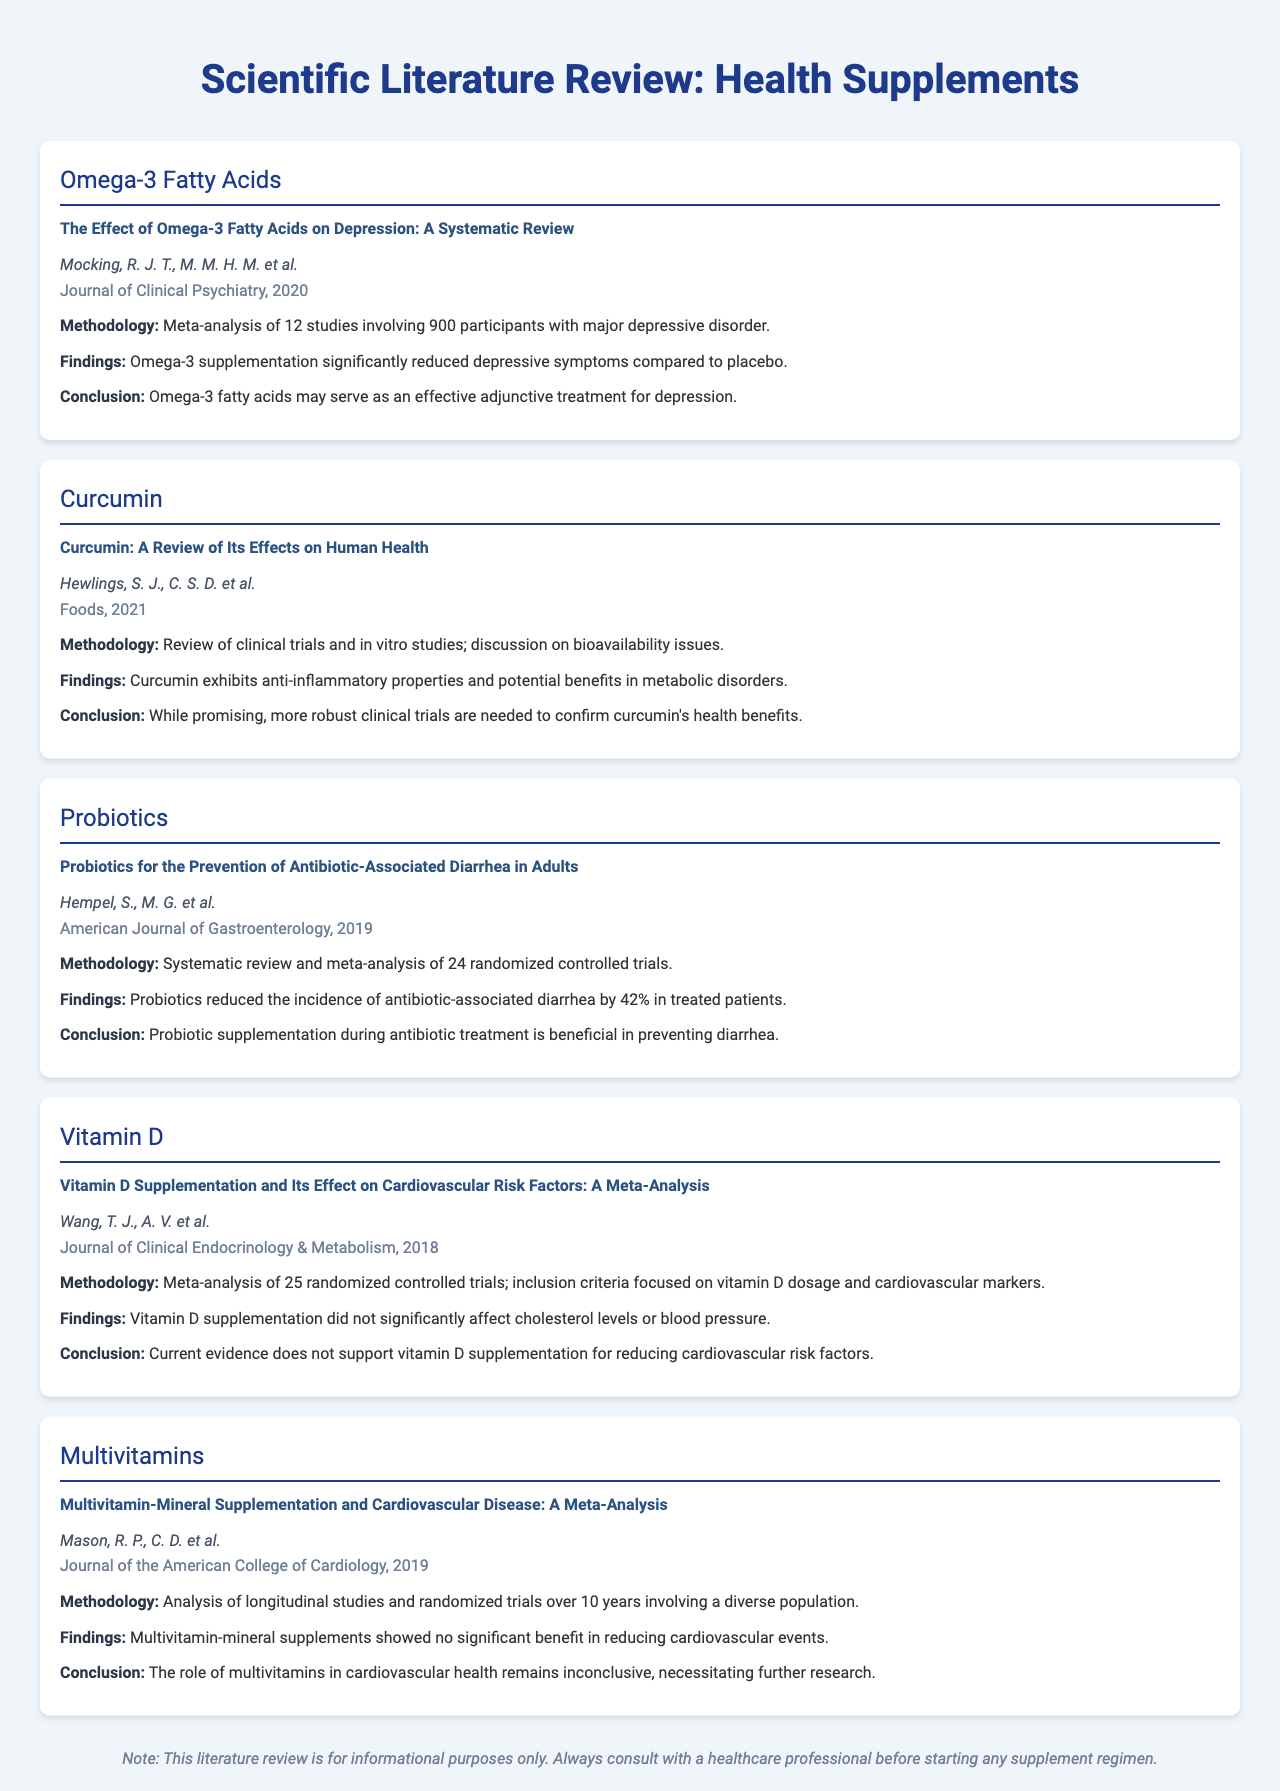What is the title of the study on Omega-3 Fatty Acids? The title of the study is explicitly mentioned within the document for Omega-3 Fatty Acids.
Answer: The Effect of Omega-3 Fatty Acids on Depression: A Systematic Review Who are the authors of the study on Curcumin? The authors of the Curcumin study are listed directly beneath the title in the document.
Answer: Hewlings, S. J., C. S. D. et al What year was the Probiotics study published? The publication year is specified in the document, providing a clear reference for the Probiotics study.
Answer: 2019 How many studies were included in the Vitamin D meta-analysis? The document outlines the details of the Vitamin D study, including the number of trials that were analyzed.
Answer: 25 What significant finding does the studies conclude about Multivitamins and cardiovascular events? The document presents the findings of the Multivitamin study concerning cardiovascular health outcomes.
Answer: No significant benefit What is the main conclusion regarding Curcumin's health benefits? The conclusion for Curcumin is included and summarizes the necessity of further research.
Answer: More robust clinical trials are needed to confirm curcumin's health benefits What was the effect of Probiotics on antibiotic-associated diarrhea? The findings detail how probiotics impacted the incidence of a specific condition as stated in the study.
Answer: Reduced by 42% What kind of methodology was used in the Omega-3 study? Methodological details are explicitly mentioned in the document about the type of research performed.
Answer: Meta-analysis of 12 studies Which journal published the Vitamin D research? The publication information is provided within each study section, indicating where the research was published.
Answer: Journal of Clinical Endocrinology & Metabolism 